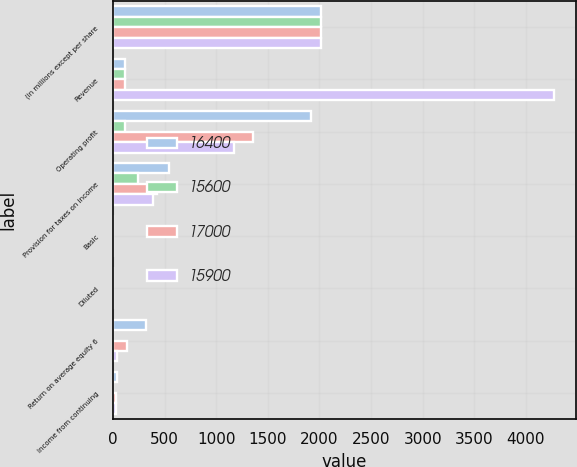Convert chart to OTSL. <chart><loc_0><loc_0><loc_500><loc_500><stacked_bar_chart><ecel><fcel>(in millions except per share<fcel>Revenue<fcel>Operating profit<fcel>Provision for taxes on income<fcel>Basic<fcel>Diluted<fcel>Return on average equity 6<fcel>Income from continuing<nl><fcel>16400<fcel>2015<fcel>113<fcel>1917<fcel>547<fcel>4.26<fcel>4.21<fcel>324.3<fcel>34.2<nl><fcel>15600<fcel>2014<fcel>113<fcel>113<fcel>245<fcel>1.08<fcel>1.08<fcel>1.4<fcel>1.1<nl><fcel>17000<fcel>2013<fcel>113<fcel>1358<fcel>425<fcel>2.85<fcel>2.8<fcel>134.2<fcel>27.6<nl><fcel>15900<fcel>2012<fcel>4270<fcel>1170<fcel>388<fcel>2.33<fcel>2.29<fcel>40.5<fcel>25.5<nl></chart> 